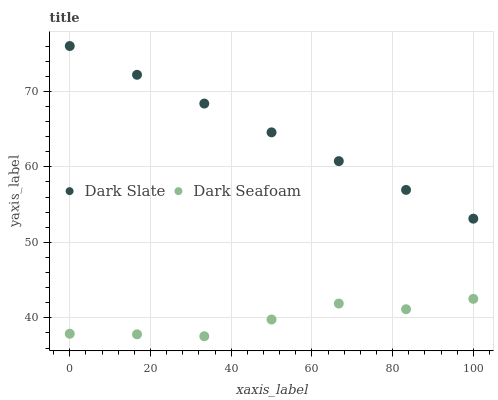Does Dark Seafoam have the minimum area under the curve?
Answer yes or no. Yes. Does Dark Slate have the maximum area under the curve?
Answer yes or no. Yes. Does Dark Seafoam have the maximum area under the curve?
Answer yes or no. No. Is Dark Slate the smoothest?
Answer yes or no. Yes. Is Dark Seafoam the roughest?
Answer yes or no. Yes. Is Dark Seafoam the smoothest?
Answer yes or no. No. Does Dark Seafoam have the lowest value?
Answer yes or no. Yes. Does Dark Slate have the highest value?
Answer yes or no. Yes. Does Dark Seafoam have the highest value?
Answer yes or no. No. Is Dark Seafoam less than Dark Slate?
Answer yes or no. Yes. Is Dark Slate greater than Dark Seafoam?
Answer yes or no. Yes. Does Dark Seafoam intersect Dark Slate?
Answer yes or no. No. 